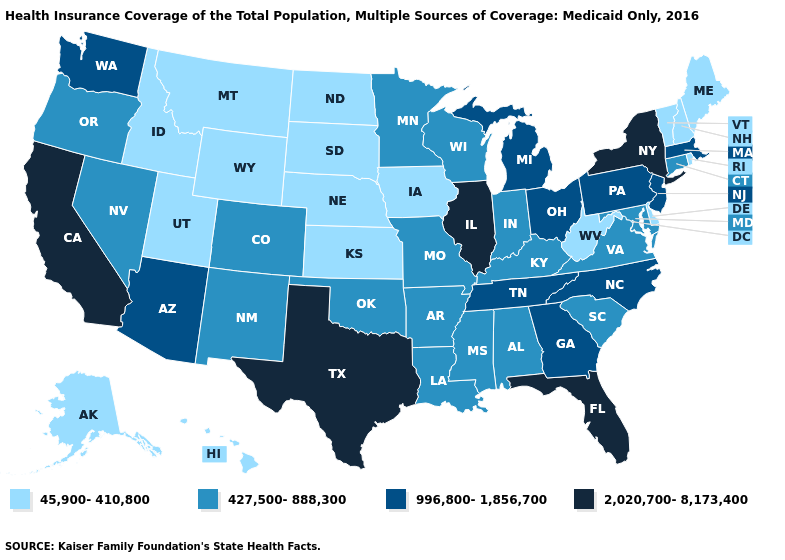What is the value of Delaware?
Concise answer only. 45,900-410,800. Which states have the highest value in the USA?
Be succinct. California, Florida, Illinois, New York, Texas. What is the value of Maine?
Answer briefly. 45,900-410,800. What is the value of Arkansas?
Give a very brief answer. 427,500-888,300. Does the map have missing data?
Concise answer only. No. What is the highest value in the West ?
Keep it brief. 2,020,700-8,173,400. Name the states that have a value in the range 427,500-888,300?
Be succinct. Alabama, Arkansas, Colorado, Connecticut, Indiana, Kentucky, Louisiana, Maryland, Minnesota, Mississippi, Missouri, Nevada, New Mexico, Oklahoma, Oregon, South Carolina, Virginia, Wisconsin. Name the states that have a value in the range 45,900-410,800?
Keep it brief. Alaska, Delaware, Hawaii, Idaho, Iowa, Kansas, Maine, Montana, Nebraska, New Hampshire, North Dakota, Rhode Island, South Dakota, Utah, Vermont, West Virginia, Wyoming. Does the first symbol in the legend represent the smallest category?
Give a very brief answer. Yes. What is the value of West Virginia?
Concise answer only. 45,900-410,800. How many symbols are there in the legend?
Short answer required. 4. Which states have the lowest value in the USA?
Be succinct. Alaska, Delaware, Hawaii, Idaho, Iowa, Kansas, Maine, Montana, Nebraska, New Hampshire, North Dakota, Rhode Island, South Dakota, Utah, Vermont, West Virginia, Wyoming. What is the value of Georgia?
Be succinct. 996,800-1,856,700. Does Tennessee have a lower value than New York?
Keep it brief. Yes. Does Oregon have a lower value than South Dakota?
Answer briefly. No. 